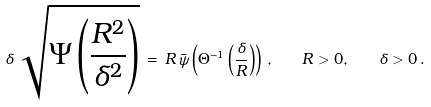<formula> <loc_0><loc_0><loc_500><loc_500>\delta \, \sqrt { \Psi \left ( \frac { R ^ { 2 } } { \delta ^ { 2 } } \right ) } \, = \, R \, \bar { \psi } \left ( \Theta ^ { - 1 } \left ( \frac { \delta } { R } \right ) \right ) \, , \quad R > 0 , \quad \delta > 0 \, .</formula> 